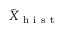<formula> <loc_0><loc_0><loc_500><loc_500>\bar { X } _ { h i s t }</formula> 